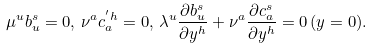<formula> <loc_0><loc_0><loc_500><loc_500>\mu ^ { u } b ^ { s } _ { u } = 0 , \, \nu ^ { a } c ^ { ^ { \prime } h } _ { a } = 0 , \, \lambda ^ { u } \frac { \partial b _ { u } ^ { s } } { \partial y ^ { h } } + \nu ^ { a } \frac { \partial c ^ { s } _ { a } } { \partial y ^ { h } } = 0 \, ( y = 0 ) .</formula> 